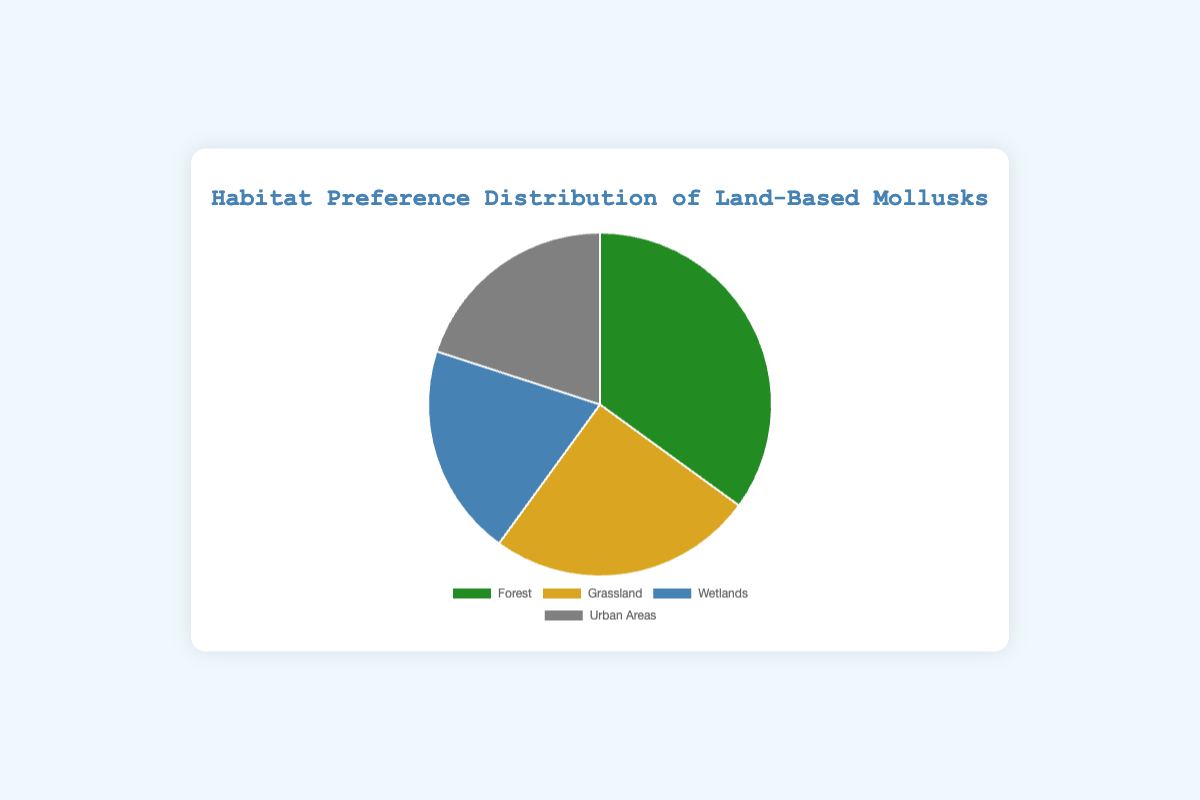What is the most preferred habitat for land-based mollusks? The segment with the highest percentage represents the most preferred habitat. The largest segment is labeled "Forest" which is 35%.
Answer: Forest Which habitats have the same preference percentage among land-based mollusks? Look for segments with identical percentages. Both "Wetlands" and "Urban Areas" have a percentage of 20%.
Answer: Wetlands and Urban Areas What is the combined percentage of land-based mollusks that prefer grasslands and wetlands? Add the percentages for Grassland and Wetlands. Grassland is 25% and Wetlands is 20%. The combined percentage is 25% + 20% = 45%.
Answer: 45% How much more preferred is the Forest habitat compared to Urban Areas? Find the difference between the percentages for Forest and Urban Areas. Forest is 35% and Urban Areas is 20%. The difference is 35% - 20% = 15%.
Answer: 15% What color represents the Grassland habitat in the chart? Identify the color associated with the Grassland segment. The Grassland segment is represented by gold color.
Answer: Gold Is the percentage of mollusks that prefer Wetlands greater than those that prefer Grassland? Compare the percentages of Wetlands and Grassland. Wetlands is 20% and Grassland is 25%, so Wetlands is not greater.
Answer: No If we combine the percentages of mollusks that prefer Urban Areas and Wetlands, does this sum equal or exceed the percentage of mollusks that prefer Forest? Add the percentages of Urban Areas and Wetlands, and compare with Forest. Urban Areas is 20%, Wetlands is 20%, combined they are 20% + 20% = 40%, which is greater than Forest's 35%.
Answer: Yes, 40% > 35% What percentage less do mollusks prefer Grassland compared to Forest? Find the difference between the percentages for Forest and Grassland. Forest is 35% and Grassland is 25%. The difference is 35% - 25% = 10%.
Answer: 10% What is the average preference percentage of all habitats combined? Add all percentages and then divide by the number of habitats. (35% + 25% + 20% + 20%) / 4 = 100% / 4 = 25%.
Answer: 25% 